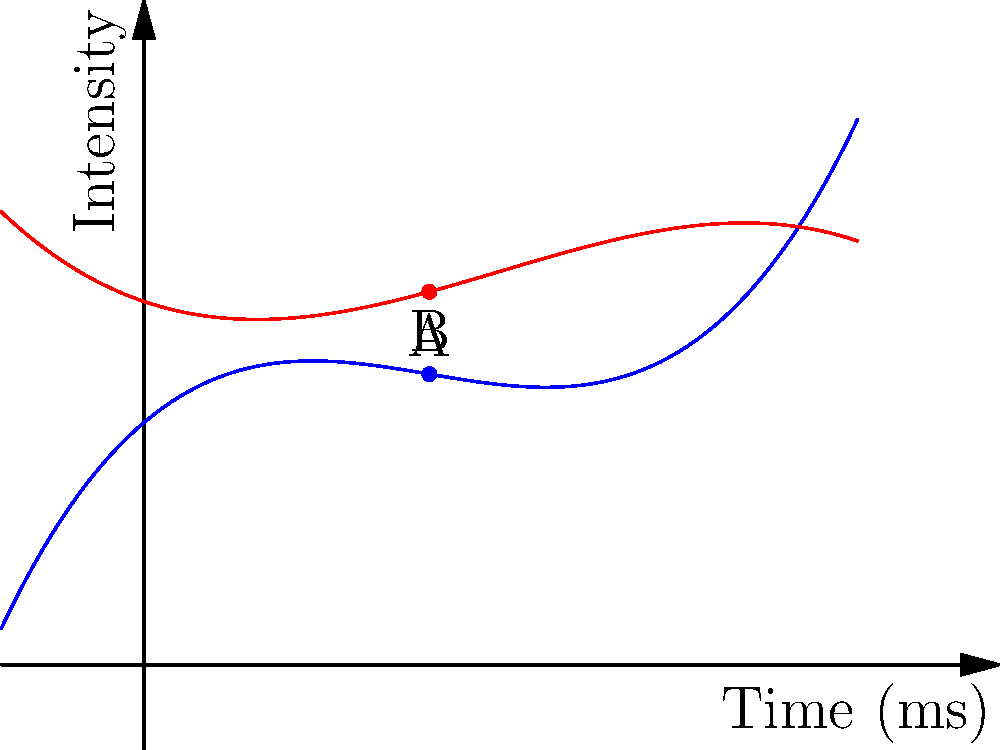In the graph above, two polynomial functions represent the intensity of a CT scan signal over time. The blue curve shows the original signal, and the red curve shows the signal after applying a polynomial-based noise reduction technique. At time $t=2$ ms, what is the percentage reduction in signal intensity achieved by the noise reduction technique? To solve this problem, we need to follow these steps:

1. Identify the intensity values at $t=2$ ms for both curves:
   - Point A (original signal): $(2, f(2))$
   - Point B (reduced noise): $(2, g(2))$

2. Calculate the intensity values:
   - $f(2) = 0.5(2)^3 - 3(2)^2 + 5(2) + 10 = 4 - 12 + 10 + 10 = 12$
   - $g(2) = -0.2(2)^3 + 1.5(2)^2 - 2(2) + 15 = -1.6 + 6 - 4 + 15 = 15.4$

3. Calculate the difference in intensity:
   $\text{Difference} = 12 - 15.4 = -3.4$

4. Calculate the percentage reduction:
   $\text{Percentage reduction} = \frac{\text{Difference}}{\text{Original intensity}} \times 100\%$
   $= \frac{-3.4}{12} \times 100\% = -28.33\%$

5. Take the absolute value of the percentage:
   $|\text{Percentage reduction}| = 28.33\%$

Therefore, the noise reduction technique achieved a 28.33% reduction in signal intensity at $t=2$ ms.
Answer: 28.33% 